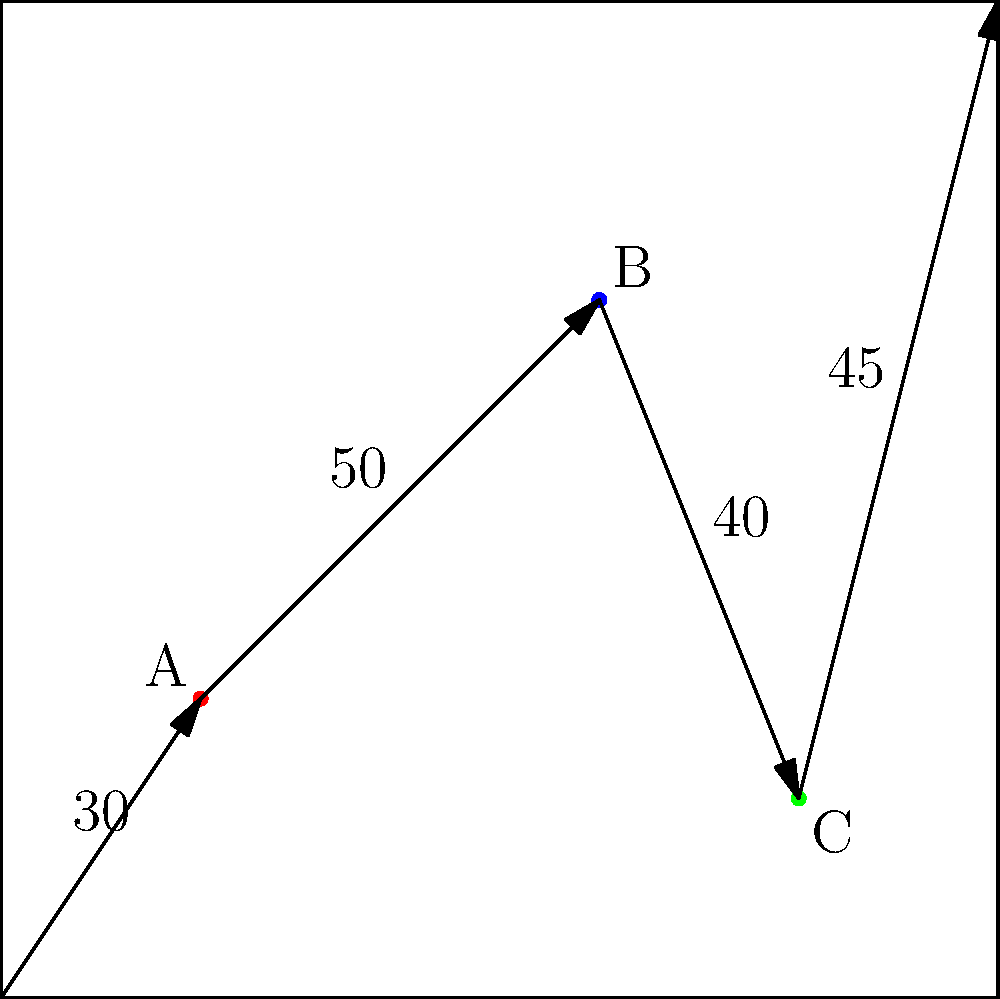In a strategy game, you need to gather resources from points A, B, and C before reaching the goal at (100, 100). Given the distances between points as shown in the map, what is the total distance traveled if you follow the most efficient route? To find the most efficient route, we need to visit all resource points while minimizing the total distance traveled. Let's break it down step-by-step:

1. Starting point to A: 30 units
2. A to B: 50 units
3. B to C: 40 units
4. C to goal (100, 100): 45 units

The most efficient route is to visit the points in the order: Start → A → B → C → Goal

To calculate the total distance:

$$\text{Total Distance} = 30 + 50 + 40 + 45 = 165\text{ units}$$

This route ensures that all resource points are visited with the minimum possible distance traveled.
Answer: 165 units 